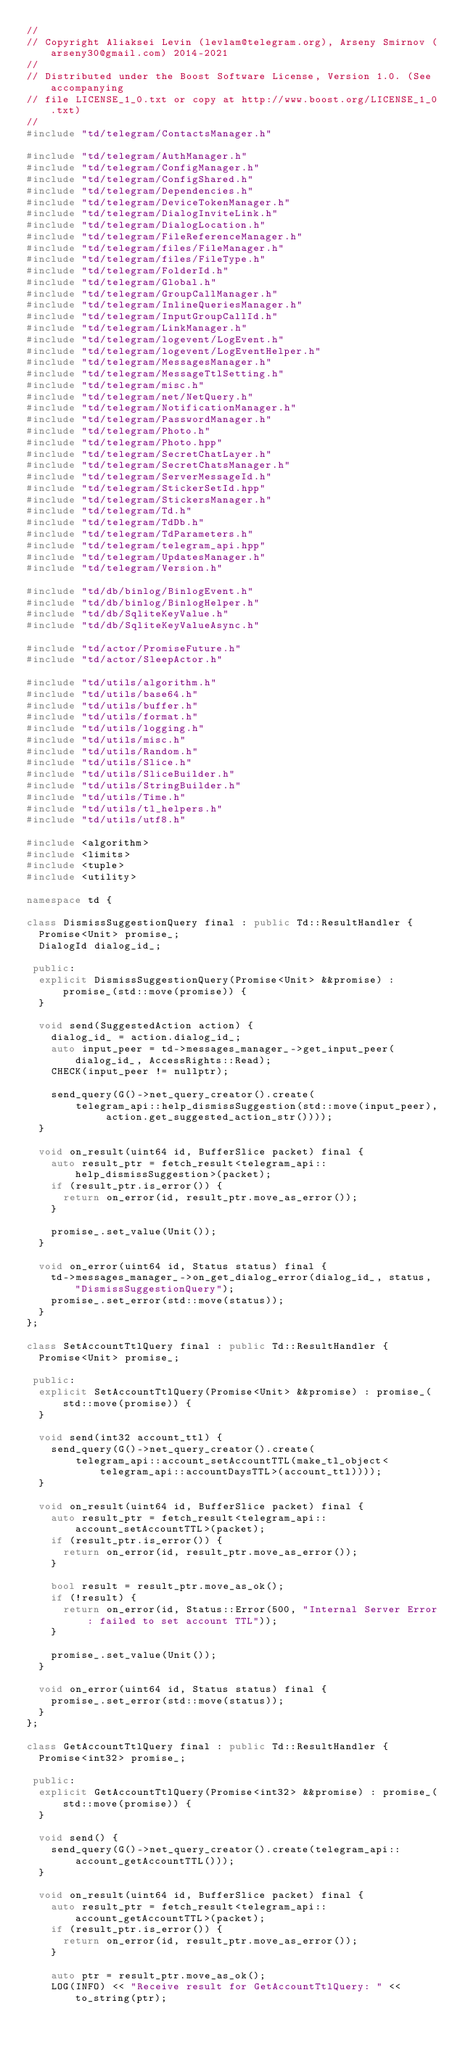<code> <loc_0><loc_0><loc_500><loc_500><_C++_>//
// Copyright Aliaksei Levin (levlam@telegram.org), Arseny Smirnov (arseny30@gmail.com) 2014-2021
//
// Distributed under the Boost Software License, Version 1.0. (See accompanying
// file LICENSE_1_0.txt or copy at http://www.boost.org/LICENSE_1_0.txt)
//
#include "td/telegram/ContactsManager.h"

#include "td/telegram/AuthManager.h"
#include "td/telegram/ConfigManager.h"
#include "td/telegram/ConfigShared.h"
#include "td/telegram/Dependencies.h"
#include "td/telegram/DeviceTokenManager.h"
#include "td/telegram/DialogInviteLink.h"
#include "td/telegram/DialogLocation.h"
#include "td/telegram/FileReferenceManager.h"
#include "td/telegram/files/FileManager.h"
#include "td/telegram/files/FileType.h"
#include "td/telegram/FolderId.h"
#include "td/telegram/Global.h"
#include "td/telegram/GroupCallManager.h"
#include "td/telegram/InlineQueriesManager.h"
#include "td/telegram/InputGroupCallId.h"
#include "td/telegram/LinkManager.h"
#include "td/telegram/logevent/LogEvent.h"
#include "td/telegram/logevent/LogEventHelper.h"
#include "td/telegram/MessagesManager.h"
#include "td/telegram/MessageTtlSetting.h"
#include "td/telegram/misc.h"
#include "td/telegram/net/NetQuery.h"
#include "td/telegram/NotificationManager.h"
#include "td/telegram/PasswordManager.h"
#include "td/telegram/Photo.h"
#include "td/telegram/Photo.hpp"
#include "td/telegram/SecretChatLayer.h"
#include "td/telegram/SecretChatsManager.h"
#include "td/telegram/ServerMessageId.h"
#include "td/telegram/StickerSetId.hpp"
#include "td/telegram/StickersManager.h"
#include "td/telegram/Td.h"
#include "td/telegram/TdDb.h"
#include "td/telegram/TdParameters.h"
#include "td/telegram/telegram_api.hpp"
#include "td/telegram/UpdatesManager.h"
#include "td/telegram/Version.h"

#include "td/db/binlog/BinlogEvent.h"
#include "td/db/binlog/BinlogHelper.h"
#include "td/db/SqliteKeyValue.h"
#include "td/db/SqliteKeyValueAsync.h"

#include "td/actor/PromiseFuture.h"
#include "td/actor/SleepActor.h"

#include "td/utils/algorithm.h"
#include "td/utils/base64.h"
#include "td/utils/buffer.h"
#include "td/utils/format.h"
#include "td/utils/logging.h"
#include "td/utils/misc.h"
#include "td/utils/Random.h"
#include "td/utils/Slice.h"
#include "td/utils/SliceBuilder.h"
#include "td/utils/StringBuilder.h"
#include "td/utils/Time.h"
#include "td/utils/tl_helpers.h"
#include "td/utils/utf8.h"

#include <algorithm>
#include <limits>
#include <tuple>
#include <utility>

namespace td {

class DismissSuggestionQuery final : public Td::ResultHandler {
  Promise<Unit> promise_;
  DialogId dialog_id_;

 public:
  explicit DismissSuggestionQuery(Promise<Unit> &&promise) : promise_(std::move(promise)) {
  }

  void send(SuggestedAction action) {
    dialog_id_ = action.dialog_id_;
    auto input_peer = td->messages_manager_->get_input_peer(dialog_id_, AccessRights::Read);
    CHECK(input_peer != nullptr);

    send_query(G()->net_query_creator().create(
        telegram_api::help_dismissSuggestion(std::move(input_peer), action.get_suggested_action_str())));
  }

  void on_result(uint64 id, BufferSlice packet) final {
    auto result_ptr = fetch_result<telegram_api::help_dismissSuggestion>(packet);
    if (result_ptr.is_error()) {
      return on_error(id, result_ptr.move_as_error());
    }

    promise_.set_value(Unit());
  }

  void on_error(uint64 id, Status status) final {
    td->messages_manager_->on_get_dialog_error(dialog_id_, status, "DismissSuggestionQuery");
    promise_.set_error(std::move(status));
  }
};

class SetAccountTtlQuery final : public Td::ResultHandler {
  Promise<Unit> promise_;

 public:
  explicit SetAccountTtlQuery(Promise<Unit> &&promise) : promise_(std::move(promise)) {
  }

  void send(int32 account_ttl) {
    send_query(G()->net_query_creator().create(
        telegram_api::account_setAccountTTL(make_tl_object<telegram_api::accountDaysTTL>(account_ttl))));
  }

  void on_result(uint64 id, BufferSlice packet) final {
    auto result_ptr = fetch_result<telegram_api::account_setAccountTTL>(packet);
    if (result_ptr.is_error()) {
      return on_error(id, result_ptr.move_as_error());
    }

    bool result = result_ptr.move_as_ok();
    if (!result) {
      return on_error(id, Status::Error(500, "Internal Server Error: failed to set account TTL"));
    }

    promise_.set_value(Unit());
  }

  void on_error(uint64 id, Status status) final {
    promise_.set_error(std::move(status));
  }
};

class GetAccountTtlQuery final : public Td::ResultHandler {
  Promise<int32> promise_;

 public:
  explicit GetAccountTtlQuery(Promise<int32> &&promise) : promise_(std::move(promise)) {
  }

  void send() {
    send_query(G()->net_query_creator().create(telegram_api::account_getAccountTTL()));
  }

  void on_result(uint64 id, BufferSlice packet) final {
    auto result_ptr = fetch_result<telegram_api::account_getAccountTTL>(packet);
    if (result_ptr.is_error()) {
      return on_error(id, result_ptr.move_as_error());
    }

    auto ptr = result_ptr.move_as_ok();
    LOG(INFO) << "Receive result for GetAccountTtlQuery: " << to_string(ptr);
</code> 